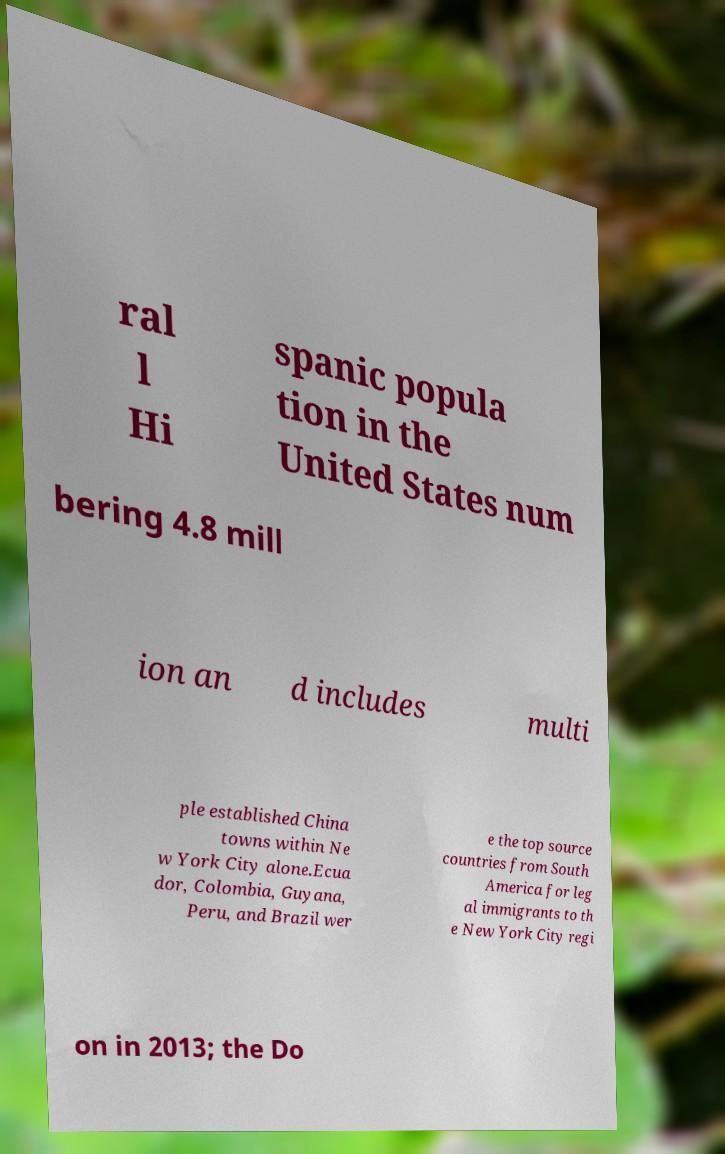There's text embedded in this image that I need extracted. Can you transcribe it verbatim? ral l Hi spanic popula tion in the United States num bering 4.8 mill ion an d includes multi ple established China towns within Ne w York City alone.Ecua dor, Colombia, Guyana, Peru, and Brazil wer e the top source countries from South America for leg al immigrants to th e New York City regi on in 2013; the Do 